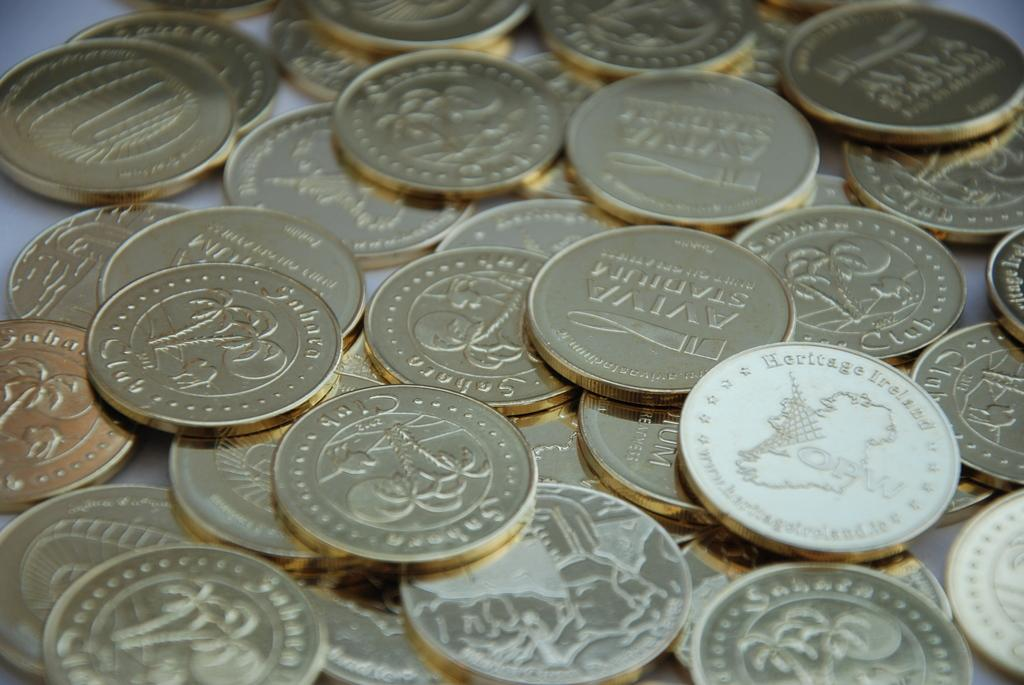Provide a one-sentence caption for the provided image. pile of goldish coins, one labeled Heritage Ireland. 